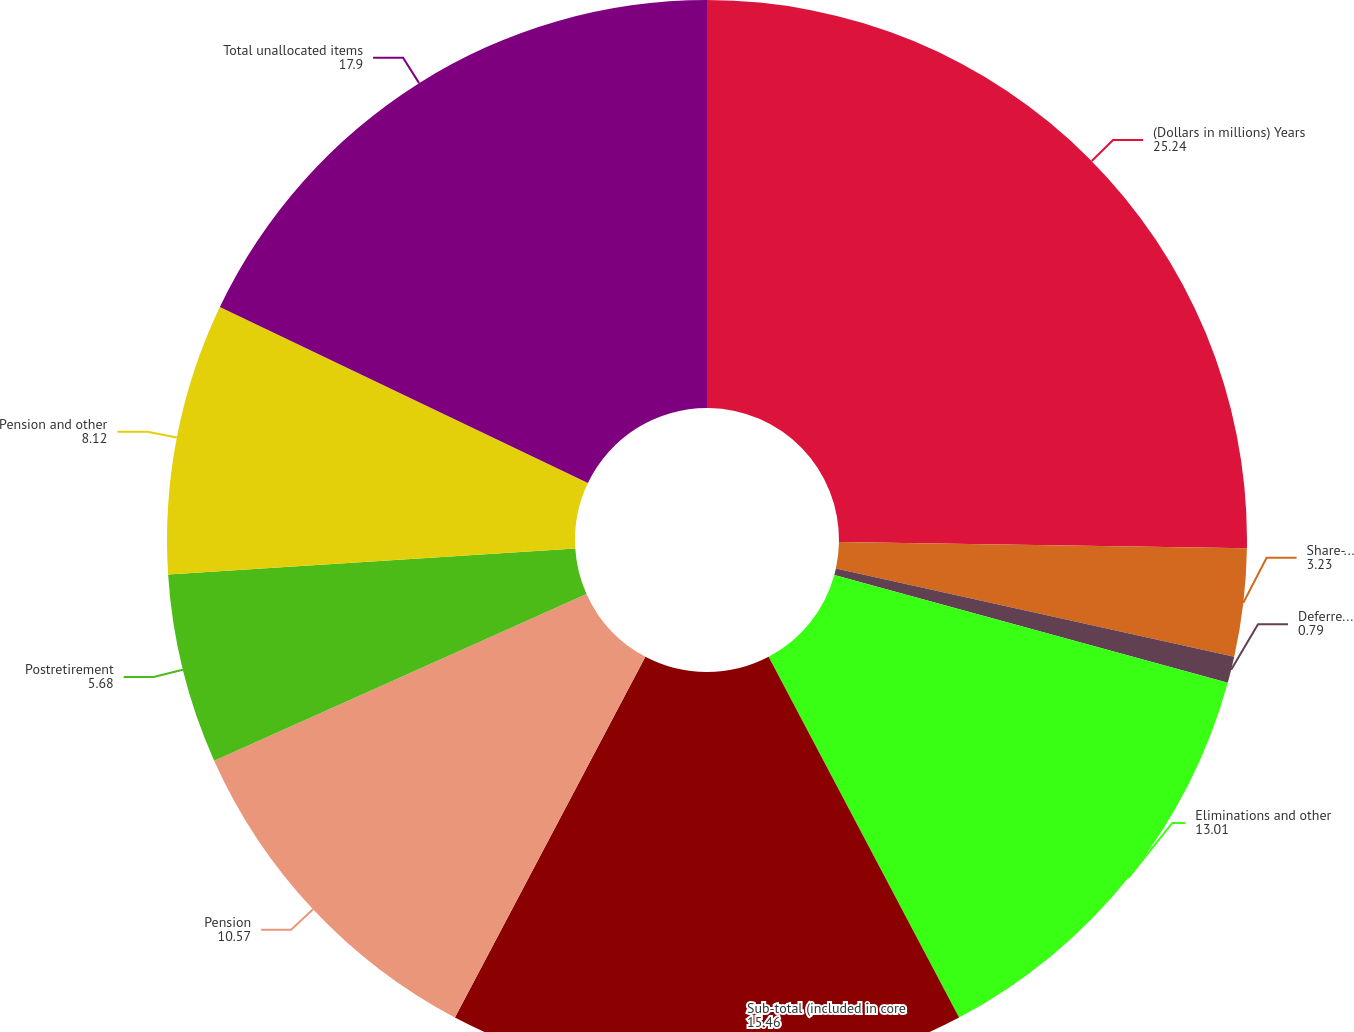Convert chart to OTSL. <chart><loc_0><loc_0><loc_500><loc_500><pie_chart><fcel>(Dollars in millions) Years<fcel>Share-based plans<fcel>Deferred compensation<fcel>Eliminations and other<fcel>Sub-total (included in core<fcel>Pension<fcel>Postretirement<fcel>Pension and other<fcel>Total unallocated items<nl><fcel>25.24%<fcel>3.23%<fcel>0.79%<fcel>13.01%<fcel>15.46%<fcel>10.57%<fcel>5.68%<fcel>8.12%<fcel>17.9%<nl></chart> 